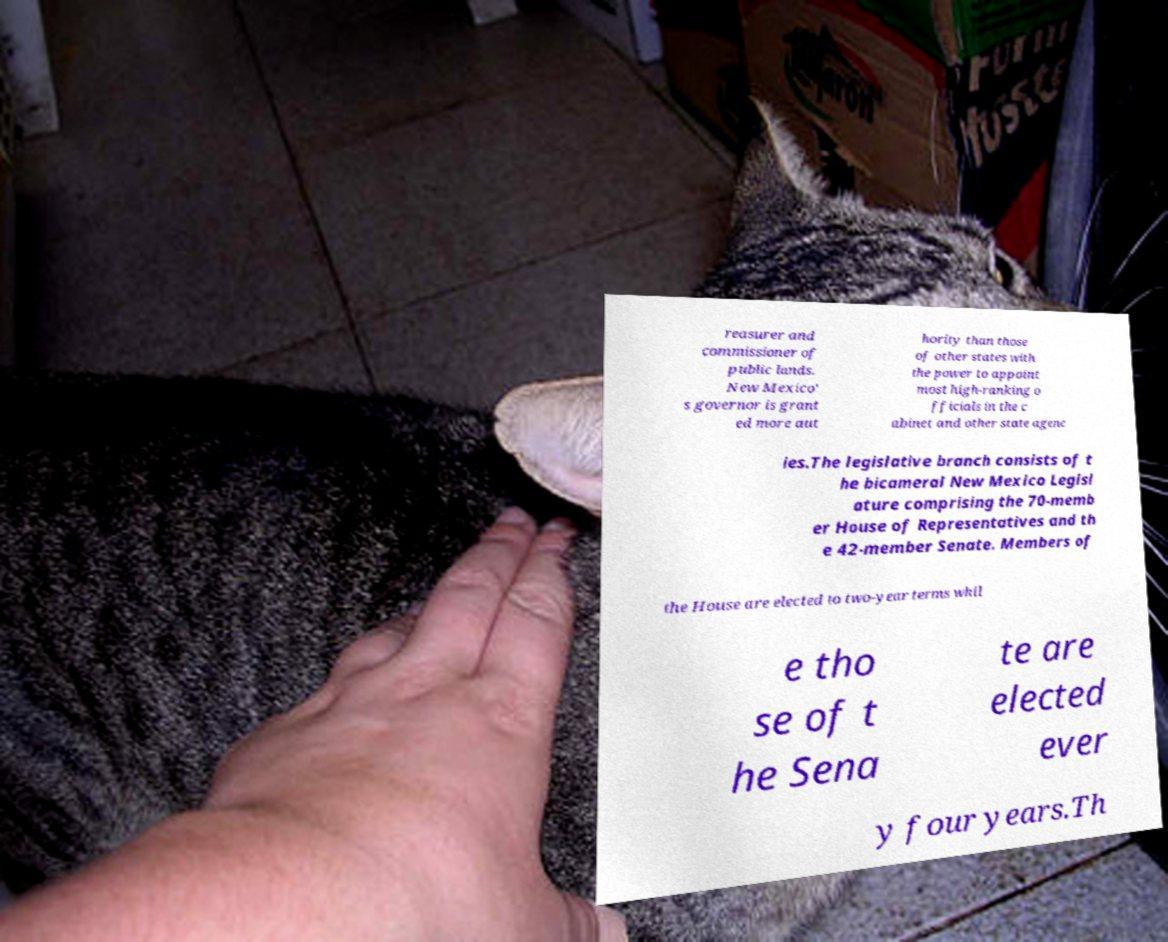Please read and relay the text visible in this image. What does it say? reasurer and commissioner of public lands. New Mexico' s governor is grant ed more aut hority than those of other states with the power to appoint most high-ranking o fficials in the c abinet and other state agenc ies.The legislative branch consists of t he bicameral New Mexico Legisl ature comprising the 70-memb er House of Representatives and th e 42-member Senate. Members of the House are elected to two-year terms whil e tho se of t he Sena te are elected ever y four years.Th 